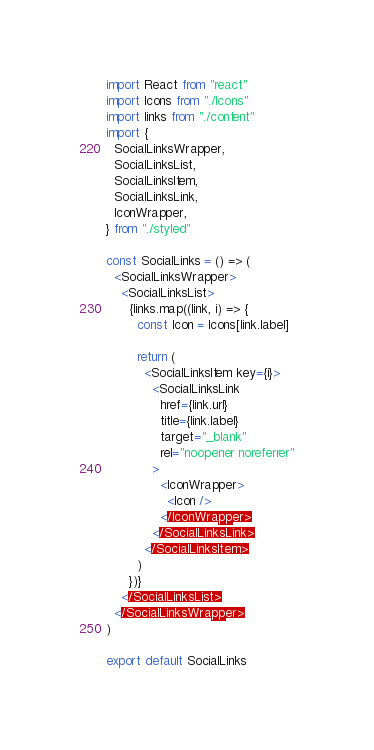<code> <loc_0><loc_0><loc_500><loc_500><_JavaScript_>import React from "react"
import Icons from "./Icons"
import links from "./content"
import {
  SocialLinksWrapper,
  SocialLinksList,
  SocialLinksItem,
  SocialLinksLink,
  IconWrapper,
} from "./styled"

const SocialLinks = () => (
  <SocialLinksWrapper>
    <SocialLinksList>
      {links.map((link, i) => {
        const Icon = Icons[link.label]

        return (
          <SocialLinksItem key={i}>
            <SocialLinksLink
              href={link.url}
              title={link.label}
              target="_blank"
              rel="noopener noreferrer"
            >
              <IconWrapper>
                <Icon />
              </IconWrapper>
            </SocialLinksLink>
          </SocialLinksItem>
        )
      })}
    </SocialLinksList>
  </SocialLinksWrapper>
)

export default SocialLinks
</code> 